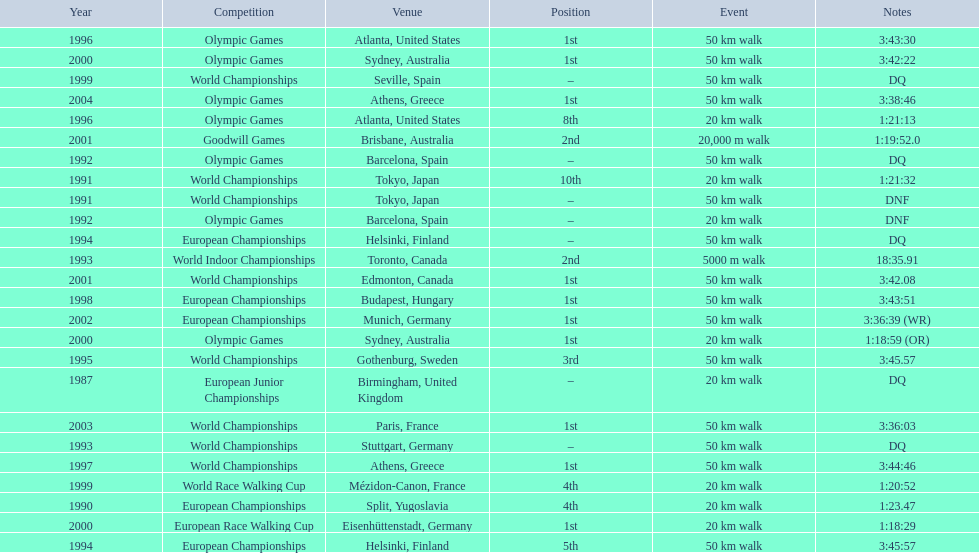Parse the table in full. {'header': ['Year', 'Competition', 'Venue', 'Position', 'Event', 'Notes'], 'rows': [['1996', 'Olympic Games', 'Atlanta, United States', '1st', '50\xa0km walk', '3:43:30'], ['2000', 'Olympic Games', 'Sydney, Australia', '1st', '50\xa0km walk', '3:42:22'], ['1999', 'World Championships', 'Seville, Spain', '–', '50\xa0km walk', 'DQ'], ['2004', 'Olympic Games', 'Athens, Greece', '1st', '50\xa0km walk', '3:38:46'], ['1996', 'Olympic Games', 'Atlanta, United States', '8th', '20\xa0km walk', '1:21:13'], ['2001', 'Goodwill Games', 'Brisbane, Australia', '2nd', '20,000 m walk', '1:19:52.0'], ['1992', 'Olympic Games', 'Barcelona, Spain', '–', '50\xa0km walk', 'DQ'], ['1991', 'World Championships', 'Tokyo, Japan', '10th', '20\xa0km walk', '1:21:32'], ['1991', 'World Championships', 'Tokyo, Japan', '–', '50\xa0km walk', 'DNF'], ['1992', 'Olympic Games', 'Barcelona, Spain', '–', '20\xa0km walk', 'DNF'], ['1994', 'European Championships', 'Helsinki, Finland', '–', '50\xa0km walk', 'DQ'], ['1993', 'World Indoor Championships', 'Toronto, Canada', '2nd', '5000 m walk', '18:35.91'], ['2001', 'World Championships', 'Edmonton, Canada', '1st', '50\xa0km walk', '3:42.08'], ['1998', 'European Championships', 'Budapest, Hungary', '1st', '50\xa0km walk', '3:43:51'], ['2002', 'European Championships', 'Munich, Germany', '1st', '50\xa0km walk', '3:36:39 (WR)'], ['2000', 'Olympic Games', 'Sydney, Australia', '1st', '20\xa0km walk', '1:18:59 (OR)'], ['1995', 'World Championships', 'Gothenburg, Sweden', '3rd', '50\xa0km walk', '3:45.57'], ['1987', 'European Junior Championships', 'Birmingham, United Kingdom', '–', '20\xa0km walk', 'DQ'], ['2003', 'World Championships', 'Paris, France', '1st', '50\xa0km walk', '3:36:03'], ['1993', 'World Championships', 'Stuttgart, Germany', '–', '50\xa0km walk', 'DQ'], ['1997', 'World Championships', 'Athens, Greece', '1st', '50\xa0km walk', '3:44:46'], ['1999', 'World Race Walking Cup', 'Mézidon-Canon, France', '4th', '20\xa0km walk', '1:20:52'], ['1990', 'European Championships', 'Split, Yugoslavia', '4th', '20\xa0km walk', '1:23.47'], ['2000', 'European Race Walking Cup', 'Eisenhüttenstadt, Germany', '1st', '20\xa0km walk', '1:18:29'], ['1994', 'European Championships', 'Helsinki, Finland', '5th', '50\xa0km walk', '3:45:57']]} How many times did korzeniowski finish above fourth place? 13. 